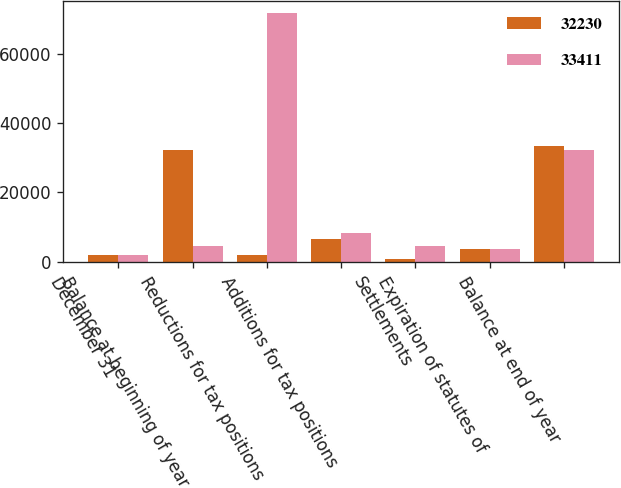Convert chart. <chart><loc_0><loc_0><loc_500><loc_500><stacked_bar_chart><ecel><fcel>December 31<fcel>Balance at beginning of year<fcel>Reductions for tax positions<fcel>Additions for tax positions<fcel>Settlements<fcel>Expiration of statutes of<fcel>Balance at end of year<nl><fcel>32230<fcel>2015<fcel>32230<fcel>2112<fcel>6623<fcel>702<fcel>3750<fcel>33411<nl><fcel>33411<fcel>2014<fcel>4643<fcel>71643<fcel>8403<fcel>4643<fcel>3850<fcel>32230<nl></chart> 